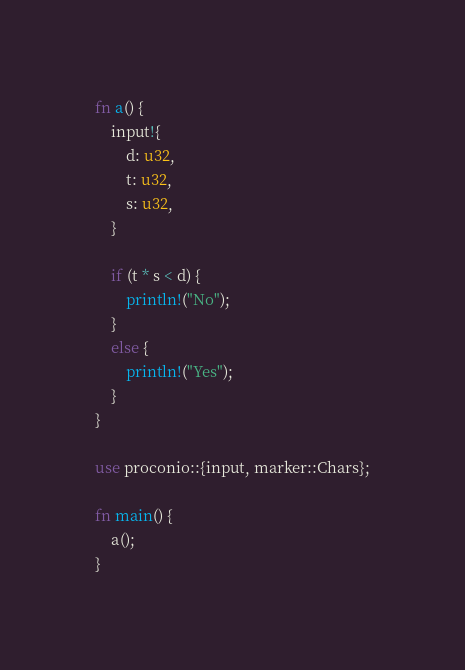<code> <loc_0><loc_0><loc_500><loc_500><_Rust_>fn a() {
    input!{
        d: u32,
        t: u32,
        s: u32,
    }

    if (t * s < d) {
        println!("No");
    }
    else {
        println!("Yes");
    }
}

use proconio::{input, marker::Chars};

fn main() {
    a();
}
</code> 